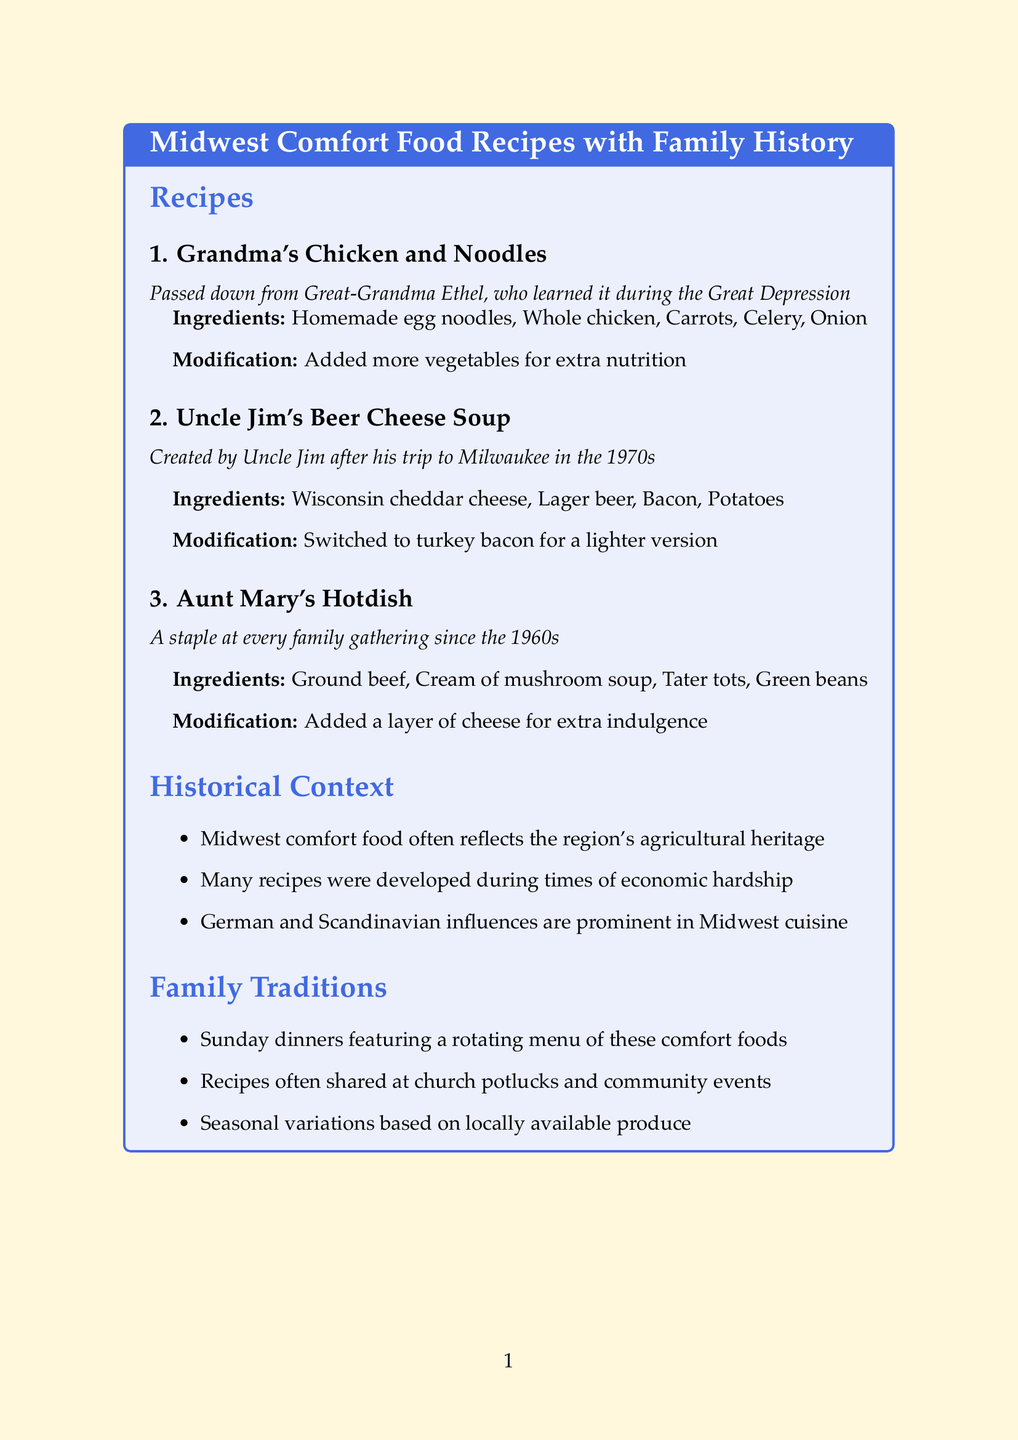What is the main title of the document? The title is explicitly provided at the top of the document and summarizes the content of the recipes and family history.
Answer: Midwest Comfort Food Recipes with Family History Who created Uncle Jim's Beer Cheese Soup? The document attributes the creation of the soup to a specific family member who is named in the recipe section.
Answer: Uncle Jim In what decade did Aunt Mary's Hotdish become a staple at family gatherings? The document specifies the period when this dish became a tradition in the family, providing a clear temporal reference.
Answer: 1960s What ingredient is added for extra nutrition in Grandma's Chicken and Noodles? The modification section for this recipe details a specific change made to enhance the dish.
Answer: More vegetables What type of cheese is used in Uncle Jim's Beer Cheese Soup? The ingredients list explicitly mentions the type of cheese included in the soup recipe.
Answer: Wisconsin cheddar cheese How many recipes are listed in the document? Counting the recipes presented under the recipes section provides the total number of dishes mentioned.
Answer: Three What historical influence is prominent in Midwest cuisine? The historical context section details significant cultural influences that shaped the regional cuisine, which are referenced in the document.
Answer: German and Scandinavian What family tradition involves these comfort food recipes? The document describes a specific family gathering practice that features these recipes, indicating their importance in family life.
Answer: Sunday dinners 